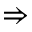<formula> <loc_0><loc_0><loc_500><loc_500>\Rightarrow</formula> 